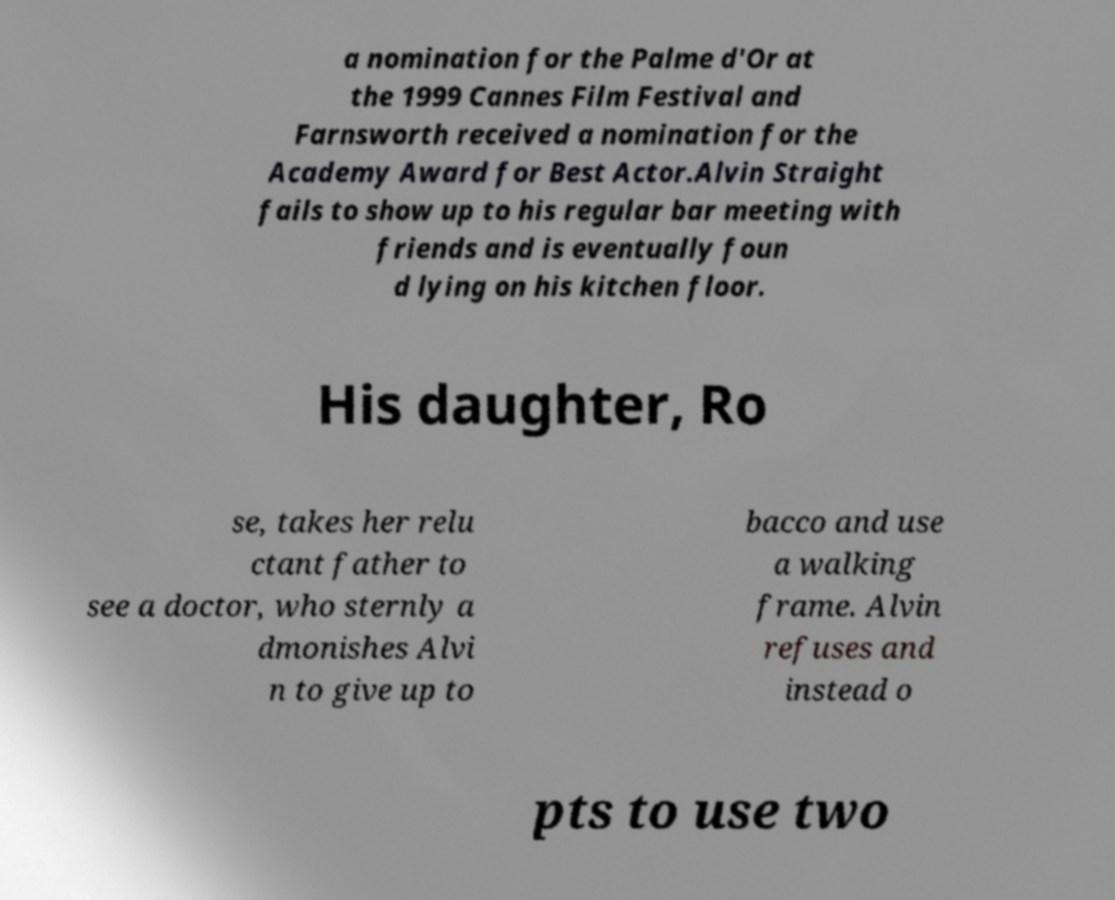Could you extract and type out the text from this image? a nomination for the Palme d'Or at the 1999 Cannes Film Festival and Farnsworth received a nomination for the Academy Award for Best Actor.Alvin Straight fails to show up to his regular bar meeting with friends and is eventually foun d lying on his kitchen floor. His daughter, Ro se, takes her relu ctant father to see a doctor, who sternly a dmonishes Alvi n to give up to bacco and use a walking frame. Alvin refuses and instead o pts to use two 